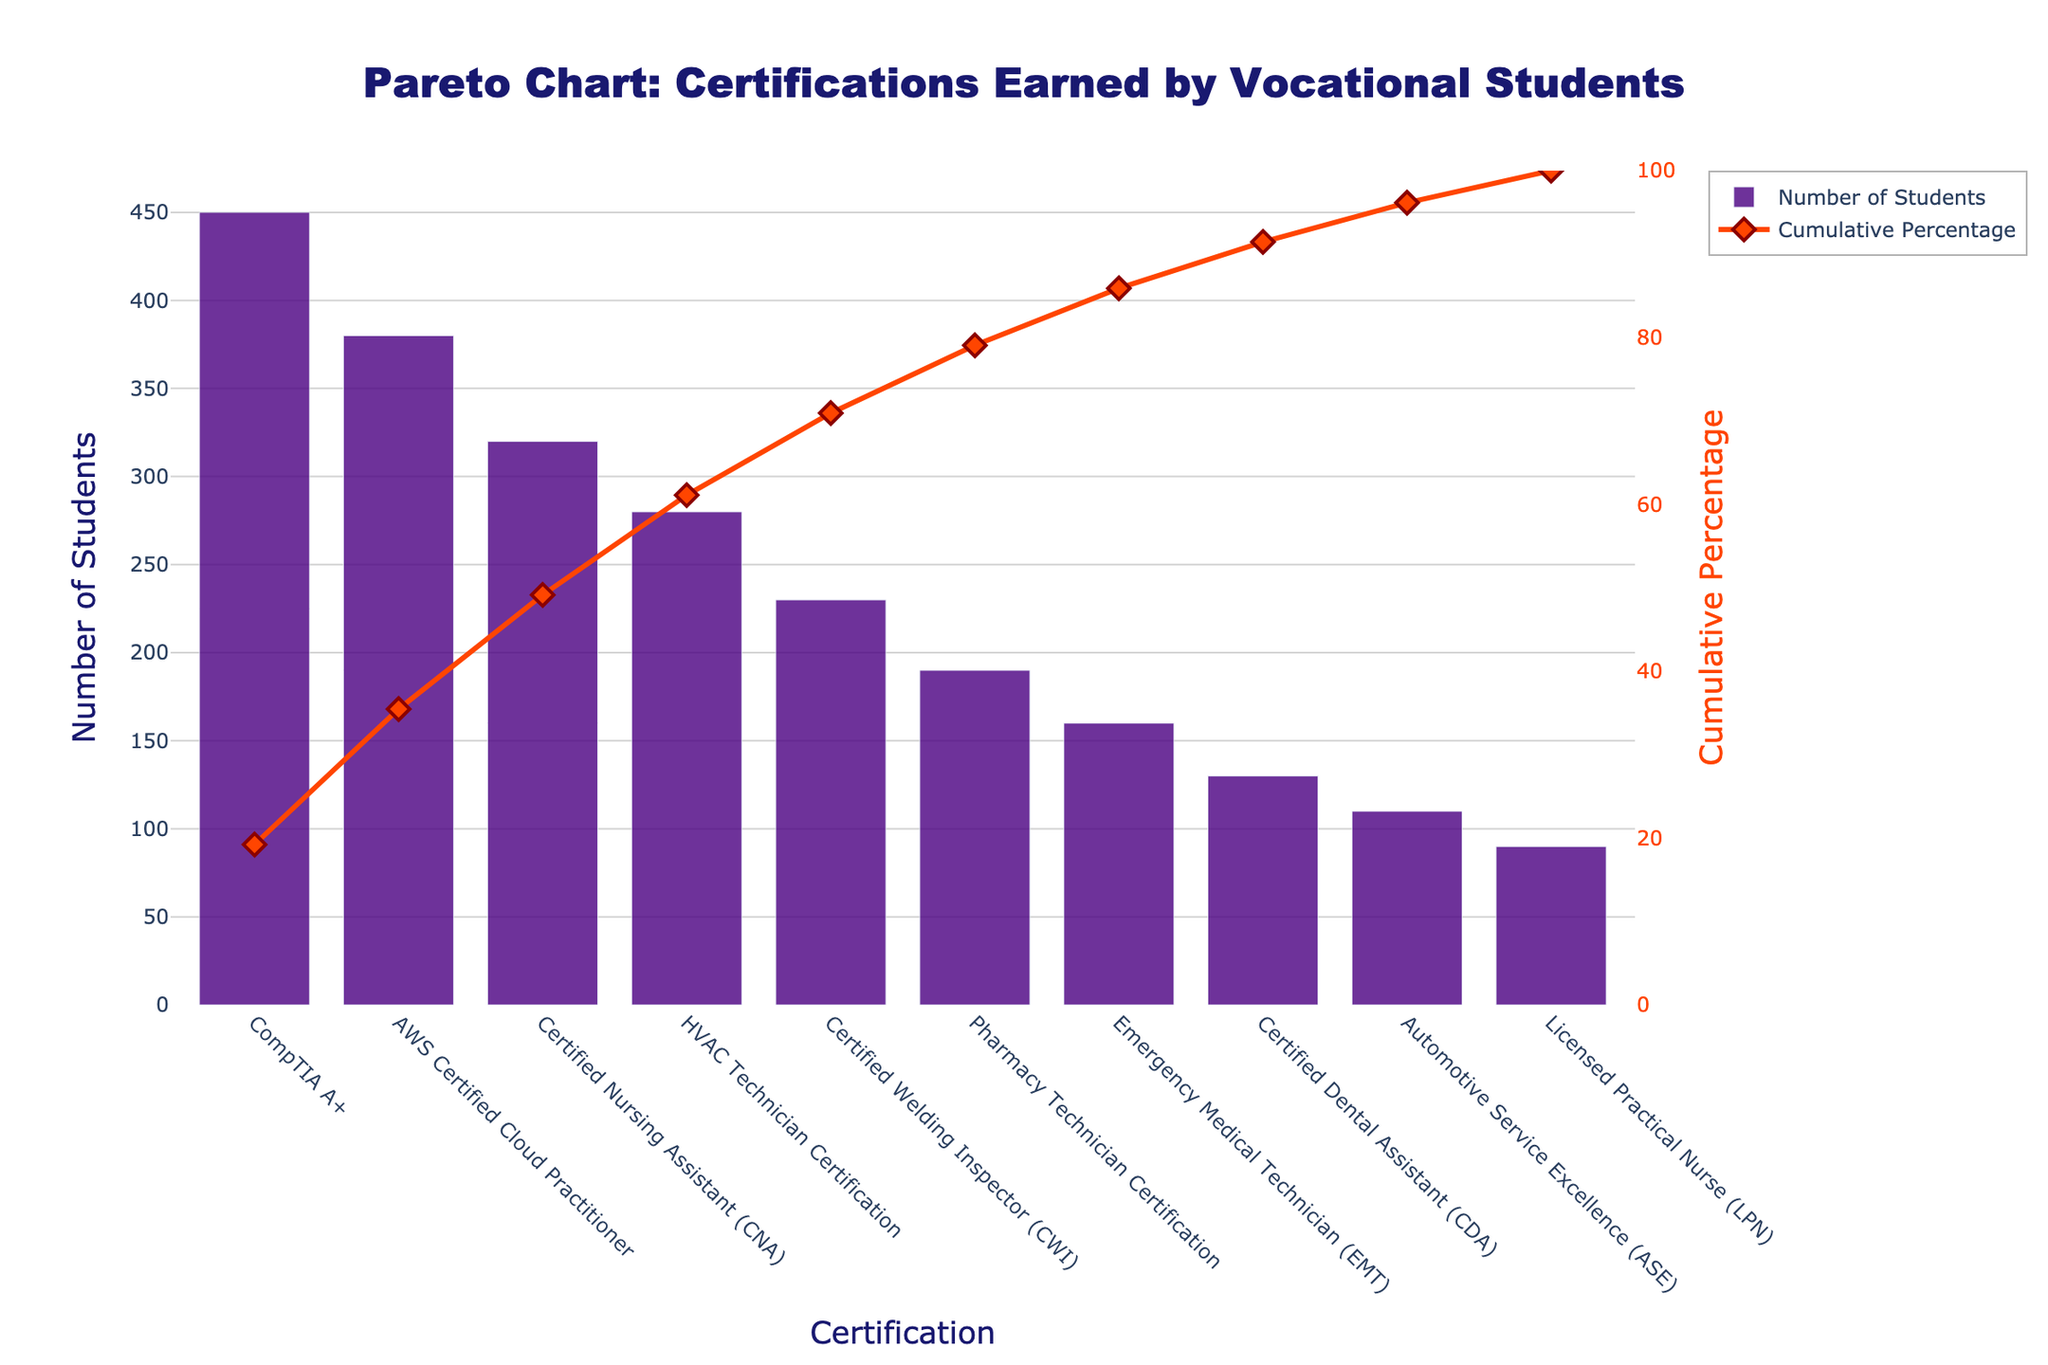What is the title of the chart? The title of the chart is displayed prominently at the top and helps understand the context of the figure. It reads "Pareto Chart: Certifications Earned by Vocational Students".
Answer: Pareto Chart: Certifications Earned by Vocational Students Which certification has the highest number of students earning it? The bar representing the certification with the highest number of students is the tallest. It corresponds to "CompTIA A+" with 450 students earning it.
Answer: CompTIA A+ How many certifications are listed in the chart? The chart shows bars for different certifications. By counting the bars, we find there are 10 certifications listed.
Answer: 10 What is the cumulative percentage for the AWS Certified Cloud Practitioner certification? The cumulative percentage for each certification is plotted as a line with markers. For AWS Certified Cloud Practitioner, this percentage is observed by finding the corresponding marker, which is at 78%.
Answer: 78% Which certification shows a cumulative percentage of approximately 55%? The line with markers representing cumulative percentages has a marker near 55%. This marker aligns with "Certified Nursing Assistant (CNA)", indicating its approximate cumulative percentage.
Answer: Certified Nursing Assistant (CNA) What is the difference in the number of students between the Emergency Medical Technician (EMT) and the Certified Welding Inspector (CWI) certifications? The bar heights show the number of students for each certification. EMT has 160 students, and CWI has 230 students. The difference is 230 - 160 = 70 students.
Answer: 70 What is the cumulative percentage range depicted on the right Y-axis? The right Y-axis represents the cumulative percentage. It starts at 0% and goes up to 100%.
Answer: 0% to 100% How many students in total earned the HVAC Technician Certification and Pharmacy Technician Certification combined? The number of students for HVAC Technician is 280 and for Pharmacy Technician is 190. Their combined total is 280 + 190 = 470 students.
Answer: 470 Which certification required the least number of students, and how many students earned it? The bar representing the certification with the fewest students is the shortest. It corresponds to "Licensed Practical Nurse (LPN)" with 90 students.
Answer: Licensed Practical Nurse (LPN), 90 What is the cumulative percentage accumulated up to the Automotive Service Excellence (ASE) certification? The cumulative percentage up to a certification is found by summing the percentages before it. For ASE, corresponding to its marker, the cumulative percentage is 98%.
Answer: 98% 